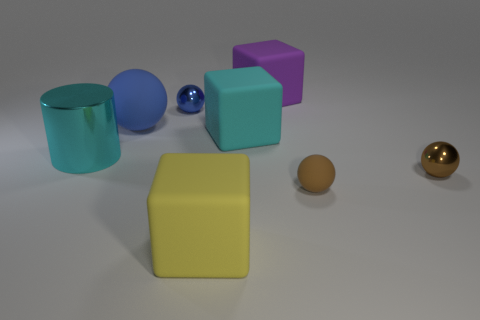Subtract all big purple cubes. How many cubes are left? 2 Add 1 blue cylinders. How many objects exist? 9 Subtract 1 cubes. How many cubes are left? 2 Subtract all cylinders. How many objects are left? 7 Add 8 cyan cubes. How many cyan cubes are left? 9 Add 8 yellow matte cubes. How many yellow matte cubes exist? 9 Subtract all brown balls. How many balls are left? 2 Subtract 2 brown spheres. How many objects are left? 6 Subtract all green cylinders. Subtract all blue balls. How many cylinders are left? 1 Subtract all purple spheres. How many yellow cylinders are left? 0 